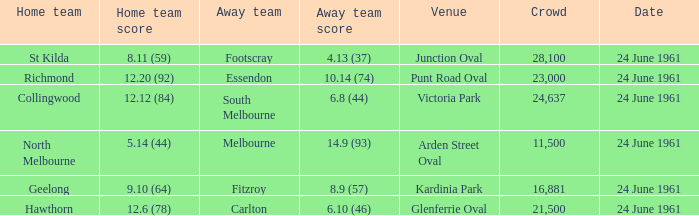What was the average crowd size of games held at Glenferrie Oval? 21500.0. 